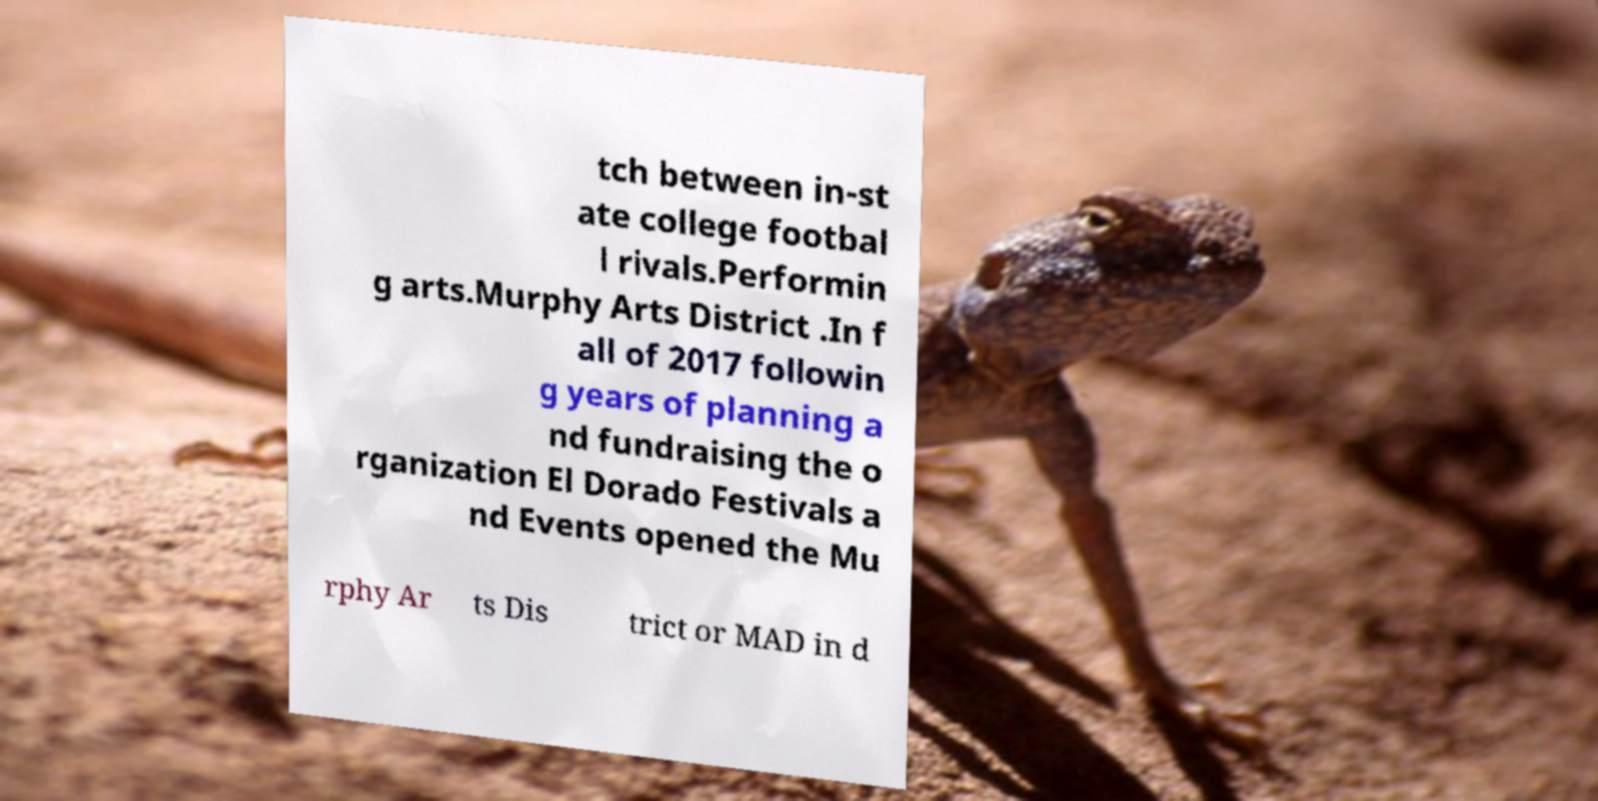Could you assist in decoding the text presented in this image and type it out clearly? tch between in-st ate college footbal l rivals.Performin g arts.Murphy Arts District .In f all of 2017 followin g years of planning a nd fundraising the o rganization El Dorado Festivals a nd Events opened the Mu rphy Ar ts Dis trict or MAD in d 